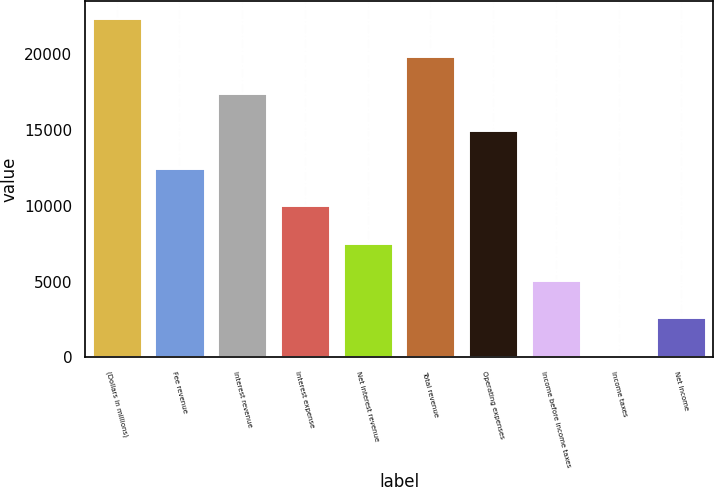Convert chart to OTSL. <chart><loc_0><loc_0><loc_500><loc_500><bar_chart><fcel>(Dollars in millions)<fcel>Fee revenue<fcel>Interest revenue<fcel>Interest expense<fcel>Net interest revenue<fcel>Total revenue<fcel>Operating expenses<fcel>Income before income taxes<fcel>Income taxes<fcel>Net Income<nl><fcel>22373.6<fcel>12500<fcel>17436.8<fcel>10031.6<fcel>7563.2<fcel>19905.2<fcel>14968.4<fcel>5094.8<fcel>158<fcel>2626.4<nl></chart> 